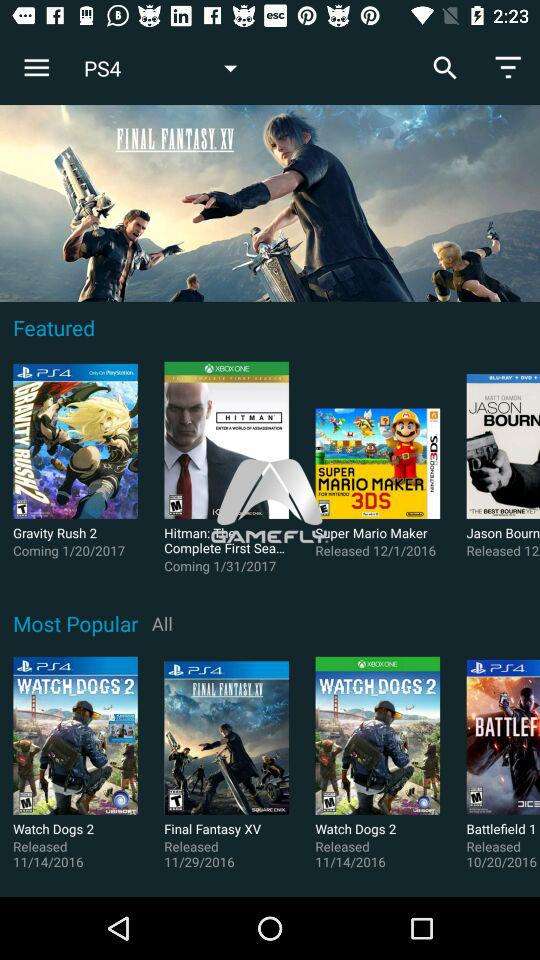What is the release date of "Super Mario Maker" game? The release date of "Super Mario Maker" game is December 1, 2016. 